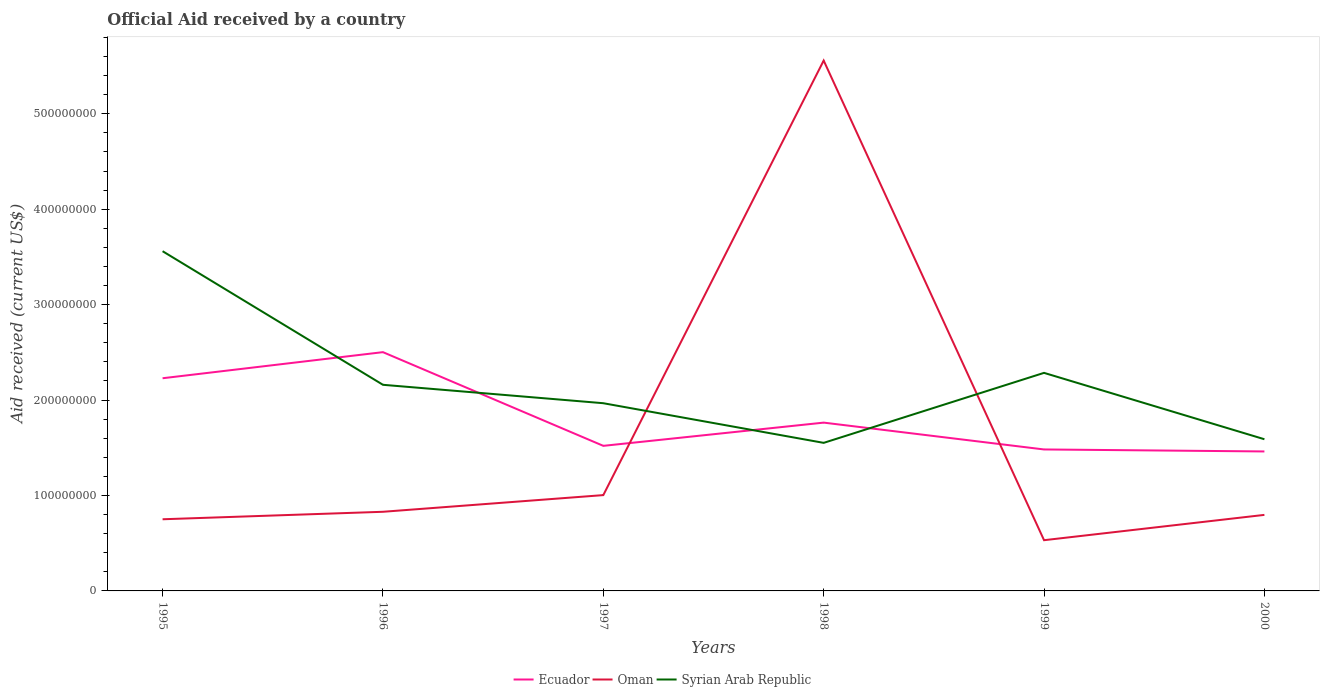How many different coloured lines are there?
Keep it short and to the point. 3. Is the number of lines equal to the number of legend labels?
Ensure brevity in your answer.  Yes. Across all years, what is the maximum net official aid received in Syrian Arab Republic?
Offer a terse response. 1.55e+08. What is the total net official aid received in Oman in the graph?
Your answer should be compact. 4.76e+08. What is the difference between the highest and the second highest net official aid received in Ecuador?
Give a very brief answer. 1.04e+08. What is the difference between the highest and the lowest net official aid received in Oman?
Offer a terse response. 1. Is the net official aid received in Ecuador strictly greater than the net official aid received in Syrian Arab Republic over the years?
Your answer should be very brief. No. How many lines are there?
Keep it short and to the point. 3. How many years are there in the graph?
Provide a short and direct response. 6. Does the graph contain any zero values?
Your answer should be compact. No. How are the legend labels stacked?
Your answer should be very brief. Horizontal. What is the title of the graph?
Provide a succinct answer. Official Aid received by a country. What is the label or title of the X-axis?
Your response must be concise. Years. What is the label or title of the Y-axis?
Provide a succinct answer. Aid received (current US$). What is the Aid received (current US$) of Ecuador in 1995?
Offer a terse response. 2.23e+08. What is the Aid received (current US$) in Oman in 1995?
Keep it short and to the point. 7.51e+07. What is the Aid received (current US$) in Syrian Arab Republic in 1995?
Offer a very short reply. 3.56e+08. What is the Aid received (current US$) in Ecuador in 1996?
Your answer should be very brief. 2.50e+08. What is the Aid received (current US$) in Oman in 1996?
Your answer should be very brief. 8.29e+07. What is the Aid received (current US$) in Syrian Arab Republic in 1996?
Provide a succinct answer. 2.16e+08. What is the Aid received (current US$) in Ecuador in 1997?
Make the answer very short. 1.52e+08. What is the Aid received (current US$) in Oman in 1997?
Ensure brevity in your answer.  1.00e+08. What is the Aid received (current US$) of Syrian Arab Republic in 1997?
Your response must be concise. 1.97e+08. What is the Aid received (current US$) of Ecuador in 1998?
Your answer should be very brief. 1.76e+08. What is the Aid received (current US$) in Oman in 1998?
Provide a short and direct response. 5.56e+08. What is the Aid received (current US$) in Syrian Arab Republic in 1998?
Provide a succinct answer. 1.55e+08. What is the Aid received (current US$) of Ecuador in 1999?
Your response must be concise. 1.48e+08. What is the Aid received (current US$) in Oman in 1999?
Ensure brevity in your answer.  5.32e+07. What is the Aid received (current US$) in Syrian Arab Republic in 1999?
Make the answer very short. 2.28e+08. What is the Aid received (current US$) of Ecuador in 2000?
Make the answer very short. 1.46e+08. What is the Aid received (current US$) of Oman in 2000?
Offer a terse response. 7.97e+07. What is the Aid received (current US$) in Syrian Arab Republic in 2000?
Your response must be concise. 1.59e+08. Across all years, what is the maximum Aid received (current US$) of Ecuador?
Keep it short and to the point. 2.50e+08. Across all years, what is the maximum Aid received (current US$) in Oman?
Provide a succinct answer. 5.56e+08. Across all years, what is the maximum Aid received (current US$) in Syrian Arab Republic?
Your response must be concise. 3.56e+08. Across all years, what is the minimum Aid received (current US$) in Ecuador?
Provide a short and direct response. 1.46e+08. Across all years, what is the minimum Aid received (current US$) of Oman?
Provide a short and direct response. 5.32e+07. Across all years, what is the minimum Aid received (current US$) in Syrian Arab Republic?
Give a very brief answer. 1.55e+08. What is the total Aid received (current US$) in Ecuador in the graph?
Your answer should be very brief. 1.10e+09. What is the total Aid received (current US$) of Oman in the graph?
Provide a succinct answer. 9.47e+08. What is the total Aid received (current US$) in Syrian Arab Republic in the graph?
Ensure brevity in your answer.  1.31e+09. What is the difference between the Aid received (current US$) of Ecuador in 1995 and that in 1996?
Give a very brief answer. -2.73e+07. What is the difference between the Aid received (current US$) in Oman in 1995 and that in 1996?
Give a very brief answer. -7.84e+06. What is the difference between the Aid received (current US$) of Syrian Arab Republic in 1995 and that in 1996?
Make the answer very short. 1.40e+08. What is the difference between the Aid received (current US$) in Ecuador in 1995 and that in 1997?
Your answer should be very brief. 7.08e+07. What is the difference between the Aid received (current US$) in Oman in 1995 and that in 1997?
Ensure brevity in your answer.  -2.53e+07. What is the difference between the Aid received (current US$) in Syrian Arab Republic in 1995 and that in 1997?
Make the answer very short. 1.59e+08. What is the difference between the Aid received (current US$) of Ecuador in 1995 and that in 1998?
Your answer should be very brief. 4.65e+07. What is the difference between the Aid received (current US$) in Oman in 1995 and that in 1998?
Your answer should be compact. -4.81e+08. What is the difference between the Aid received (current US$) of Syrian Arab Republic in 1995 and that in 1998?
Your response must be concise. 2.01e+08. What is the difference between the Aid received (current US$) of Ecuador in 1995 and that in 1999?
Keep it short and to the point. 7.46e+07. What is the difference between the Aid received (current US$) in Oman in 1995 and that in 1999?
Give a very brief answer. 2.19e+07. What is the difference between the Aid received (current US$) in Syrian Arab Republic in 1995 and that in 1999?
Your answer should be very brief. 1.27e+08. What is the difference between the Aid received (current US$) in Ecuador in 1995 and that in 2000?
Make the answer very short. 7.67e+07. What is the difference between the Aid received (current US$) in Oman in 1995 and that in 2000?
Your answer should be compact. -4.58e+06. What is the difference between the Aid received (current US$) of Syrian Arab Republic in 1995 and that in 2000?
Ensure brevity in your answer.  1.97e+08. What is the difference between the Aid received (current US$) of Ecuador in 1996 and that in 1997?
Your answer should be very brief. 9.82e+07. What is the difference between the Aid received (current US$) in Oman in 1996 and that in 1997?
Provide a succinct answer. -1.75e+07. What is the difference between the Aid received (current US$) in Syrian Arab Republic in 1996 and that in 1997?
Give a very brief answer. 1.93e+07. What is the difference between the Aid received (current US$) of Ecuador in 1996 and that in 1998?
Your answer should be very brief. 7.38e+07. What is the difference between the Aid received (current US$) in Oman in 1996 and that in 1998?
Keep it short and to the point. -4.73e+08. What is the difference between the Aid received (current US$) of Syrian Arab Republic in 1996 and that in 1998?
Keep it short and to the point. 6.08e+07. What is the difference between the Aid received (current US$) of Ecuador in 1996 and that in 1999?
Provide a short and direct response. 1.02e+08. What is the difference between the Aid received (current US$) of Oman in 1996 and that in 1999?
Make the answer very short. 2.98e+07. What is the difference between the Aid received (current US$) of Syrian Arab Republic in 1996 and that in 1999?
Your answer should be very brief. -1.25e+07. What is the difference between the Aid received (current US$) of Ecuador in 1996 and that in 2000?
Offer a very short reply. 1.04e+08. What is the difference between the Aid received (current US$) in Oman in 1996 and that in 2000?
Your answer should be very brief. 3.26e+06. What is the difference between the Aid received (current US$) of Syrian Arab Republic in 1996 and that in 2000?
Offer a very short reply. 5.70e+07. What is the difference between the Aid received (current US$) of Ecuador in 1997 and that in 1998?
Ensure brevity in your answer.  -2.43e+07. What is the difference between the Aid received (current US$) in Oman in 1997 and that in 1998?
Your answer should be very brief. -4.55e+08. What is the difference between the Aid received (current US$) of Syrian Arab Republic in 1997 and that in 1998?
Keep it short and to the point. 4.16e+07. What is the difference between the Aid received (current US$) in Ecuador in 1997 and that in 1999?
Offer a very short reply. 3.79e+06. What is the difference between the Aid received (current US$) of Oman in 1997 and that in 1999?
Make the answer very short. 4.72e+07. What is the difference between the Aid received (current US$) of Syrian Arab Republic in 1997 and that in 1999?
Ensure brevity in your answer.  -3.18e+07. What is the difference between the Aid received (current US$) in Ecuador in 1997 and that in 2000?
Your answer should be very brief. 5.88e+06. What is the difference between the Aid received (current US$) of Oman in 1997 and that in 2000?
Provide a short and direct response. 2.07e+07. What is the difference between the Aid received (current US$) in Syrian Arab Republic in 1997 and that in 2000?
Keep it short and to the point. 3.78e+07. What is the difference between the Aid received (current US$) in Ecuador in 1998 and that in 1999?
Offer a terse response. 2.81e+07. What is the difference between the Aid received (current US$) in Oman in 1998 and that in 1999?
Your answer should be very brief. 5.03e+08. What is the difference between the Aid received (current US$) of Syrian Arab Republic in 1998 and that in 1999?
Give a very brief answer. -7.34e+07. What is the difference between the Aid received (current US$) in Ecuador in 1998 and that in 2000?
Your answer should be very brief. 3.02e+07. What is the difference between the Aid received (current US$) in Oman in 1998 and that in 2000?
Your answer should be compact. 4.76e+08. What is the difference between the Aid received (current US$) in Syrian Arab Republic in 1998 and that in 2000?
Make the answer very short. -3.80e+06. What is the difference between the Aid received (current US$) of Ecuador in 1999 and that in 2000?
Provide a short and direct response. 2.09e+06. What is the difference between the Aid received (current US$) in Oman in 1999 and that in 2000?
Your answer should be very brief. -2.65e+07. What is the difference between the Aid received (current US$) of Syrian Arab Republic in 1999 and that in 2000?
Make the answer very short. 6.96e+07. What is the difference between the Aid received (current US$) of Ecuador in 1995 and the Aid received (current US$) of Oman in 1996?
Provide a short and direct response. 1.40e+08. What is the difference between the Aid received (current US$) of Ecuador in 1995 and the Aid received (current US$) of Syrian Arab Republic in 1996?
Provide a short and direct response. 6.87e+06. What is the difference between the Aid received (current US$) of Oman in 1995 and the Aid received (current US$) of Syrian Arab Republic in 1996?
Your answer should be very brief. -1.41e+08. What is the difference between the Aid received (current US$) in Ecuador in 1995 and the Aid received (current US$) in Oman in 1997?
Provide a succinct answer. 1.22e+08. What is the difference between the Aid received (current US$) of Ecuador in 1995 and the Aid received (current US$) of Syrian Arab Republic in 1997?
Ensure brevity in your answer.  2.62e+07. What is the difference between the Aid received (current US$) in Oman in 1995 and the Aid received (current US$) in Syrian Arab Republic in 1997?
Ensure brevity in your answer.  -1.22e+08. What is the difference between the Aid received (current US$) in Ecuador in 1995 and the Aid received (current US$) in Oman in 1998?
Keep it short and to the point. -3.33e+08. What is the difference between the Aid received (current US$) of Ecuador in 1995 and the Aid received (current US$) of Syrian Arab Republic in 1998?
Provide a succinct answer. 6.77e+07. What is the difference between the Aid received (current US$) in Oman in 1995 and the Aid received (current US$) in Syrian Arab Republic in 1998?
Your response must be concise. -8.00e+07. What is the difference between the Aid received (current US$) in Ecuador in 1995 and the Aid received (current US$) in Oman in 1999?
Your answer should be compact. 1.70e+08. What is the difference between the Aid received (current US$) in Ecuador in 1995 and the Aid received (current US$) in Syrian Arab Republic in 1999?
Your response must be concise. -5.63e+06. What is the difference between the Aid received (current US$) in Oman in 1995 and the Aid received (current US$) in Syrian Arab Republic in 1999?
Provide a short and direct response. -1.53e+08. What is the difference between the Aid received (current US$) of Ecuador in 1995 and the Aid received (current US$) of Oman in 2000?
Give a very brief answer. 1.43e+08. What is the difference between the Aid received (current US$) of Ecuador in 1995 and the Aid received (current US$) of Syrian Arab Republic in 2000?
Provide a succinct answer. 6.39e+07. What is the difference between the Aid received (current US$) in Oman in 1995 and the Aid received (current US$) in Syrian Arab Republic in 2000?
Offer a very short reply. -8.38e+07. What is the difference between the Aid received (current US$) of Ecuador in 1996 and the Aid received (current US$) of Oman in 1997?
Provide a succinct answer. 1.50e+08. What is the difference between the Aid received (current US$) in Ecuador in 1996 and the Aid received (current US$) in Syrian Arab Republic in 1997?
Offer a very short reply. 5.35e+07. What is the difference between the Aid received (current US$) of Oman in 1996 and the Aid received (current US$) of Syrian Arab Republic in 1997?
Give a very brief answer. -1.14e+08. What is the difference between the Aid received (current US$) of Ecuador in 1996 and the Aid received (current US$) of Oman in 1998?
Provide a succinct answer. -3.06e+08. What is the difference between the Aid received (current US$) of Ecuador in 1996 and the Aid received (current US$) of Syrian Arab Republic in 1998?
Your answer should be compact. 9.50e+07. What is the difference between the Aid received (current US$) of Oman in 1996 and the Aid received (current US$) of Syrian Arab Republic in 1998?
Provide a succinct answer. -7.22e+07. What is the difference between the Aid received (current US$) of Ecuador in 1996 and the Aid received (current US$) of Oman in 1999?
Ensure brevity in your answer.  1.97e+08. What is the difference between the Aid received (current US$) of Ecuador in 1996 and the Aid received (current US$) of Syrian Arab Republic in 1999?
Offer a terse response. 2.17e+07. What is the difference between the Aid received (current US$) in Oman in 1996 and the Aid received (current US$) in Syrian Arab Republic in 1999?
Your answer should be very brief. -1.46e+08. What is the difference between the Aid received (current US$) of Ecuador in 1996 and the Aid received (current US$) of Oman in 2000?
Offer a very short reply. 1.71e+08. What is the difference between the Aid received (current US$) of Ecuador in 1996 and the Aid received (current US$) of Syrian Arab Republic in 2000?
Give a very brief answer. 9.12e+07. What is the difference between the Aid received (current US$) of Oman in 1996 and the Aid received (current US$) of Syrian Arab Republic in 2000?
Offer a very short reply. -7.60e+07. What is the difference between the Aid received (current US$) in Ecuador in 1997 and the Aid received (current US$) in Oman in 1998?
Offer a very short reply. -4.04e+08. What is the difference between the Aid received (current US$) in Ecuador in 1997 and the Aid received (current US$) in Syrian Arab Republic in 1998?
Your response must be concise. -3.12e+06. What is the difference between the Aid received (current US$) of Oman in 1997 and the Aid received (current US$) of Syrian Arab Republic in 1998?
Make the answer very short. -5.47e+07. What is the difference between the Aid received (current US$) of Ecuador in 1997 and the Aid received (current US$) of Oman in 1999?
Your response must be concise. 9.89e+07. What is the difference between the Aid received (current US$) in Ecuador in 1997 and the Aid received (current US$) in Syrian Arab Republic in 1999?
Give a very brief answer. -7.65e+07. What is the difference between the Aid received (current US$) in Oman in 1997 and the Aid received (current US$) in Syrian Arab Republic in 1999?
Make the answer very short. -1.28e+08. What is the difference between the Aid received (current US$) in Ecuador in 1997 and the Aid received (current US$) in Oman in 2000?
Provide a short and direct response. 7.24e+07. What is the difference between the Aid received (current US$) of Ecuador in 1997 and the Aid received (current US$) of Syrian Arab Republic in 2000?
Your answer should be very brief. -6.92e+06. What is the difference between the Aid received (current US$) of Oman in 1997 and the Aid received (current US$) of Syrian Arab Republic in 2000?
Provide a succinct answer. -5.85e+07. What is the difference between the Aid received (current US$) of Ecuador in 1998 and the Aid received (current US$) of Oman in 1999?
Provide a succinct answer. 1.23e+08. What is the difference between the Aid received (current US$) of Ecuador in 1998 and the Aid received (current US$) of Syrian Arab Republic in 1999?
Offer a terse response. -5.21e+07. What is the difference between the Aid received (current US$) in Oman in 1998 and the Aid received (current US$) in Syrian Arab Republic in 1999?
Ensure brevity in your answer.  3.27e+08. What is the difference between the Aid received (current US$) in Ecuador in 1998 and the Aid received (current US$) in Oman in 2000?
Offer a very short reply. 9.67e+07. What is the difference between the Aid received (current US$) in Ecuador in 1998 and the Aid received (current US$) in Syrian Arab Republic in 2000?
Provide a short and direct response. 1.74e+07. What is the difference between the Aid received (current US$) of Oman in 1998 and the Aid received (current US$) of Syrian Arab Republic in 2000?
Ensure brevity in your answer.  3.97e+08. What is the difference between the Aid received (current US$) of Ecuador in 1999 and the Aid received (current US$) of Oman in 2000?
Provide a succinct answer. 6.86e+07. What is the difference between the Aid received (current US$) of Ecuador in 1999 and the Aid received (current US$) of Syrian Arab Republic in 2000?
Provide a succinct answer. -1.07e+07. What is the difference between the Aid received (current US$) in Oman in 1999 and the Aid received (current US$) in Syrian Arab Republic in 2000?
Provide a succinct answer. -1.06e+08. What is the average Aid received (current US$) in Ecuador per year?
Offer a very short reply. 1.83e+08. What is the average Aid received (current US$) in Oman per year?
Give a very brief answer. 1.58e+08. What is the average Aid received (current US$) in Syrian Arab Republic per year?
Give a very brief answer. 2.19e+08. In the year 1995, what is the difference between the Aid received (current US$) in Ecuador and Aid received (current US$) in Oman?
Provide a short and direct response. 1.48e+08. In the year 1995, what is the difference between the Aid received (current US$) of Ecuador and Aid received (current US$) of Syrian Arab Republic?
Your answer should be compact. -1.33e+08. In the year 1995, what is the difference between the Aid received (current US$) in Oman and Aid received (current US$) in Syrian Arab Republic?
Your response must be concise. -2.81e+08. In the year 1996, what is the difference between the Aid received (current US$) of Ecuador and Aid received (current US$) of Oman?
Provide a succinct answer. 1.67e+08. In the year 1996, what is the difference between the Aid received (current US$) of Ecuador and Aid received (current US$) of Syrian Arab Republic?
Offer a terse response. 3.42e+07. In the year 1996, what is the difference between the Aid received (current US$) in Oman and Aid received (current US$) in Syrian Arab Republic?
Provide a succinct answer. -1.33e+08. In the year 1997, what is the difference between the Aid received (current US$) in Ecuador and Aid received (current US$) in Oman?
Your response must be concise. 5.16e+07. In the year 1997, what is the difference between the Aid received (current US$) of Ecuador and Aid received (current US$) of Syrian Arab Republic?
Your response must be concise. -4.47e+07. In the year 1997, what is the difference between the Aid received (current US$) in Oman and Aid received (current US$) in Syrian Arab Republic?
Offer a very short reply. -9.63e+07. In the year 1998, what is the difference between the Aid received (current US$) in Ecuador and Aid received (current US$) in Oman?
Offer a terse response. -3.79e+08. In the year 1998, what is the difference between the Aid received (current US$) in Ecuador and Aid received (current US$) in Syrian Arab Republic?
Offer a very short reply. 2.12e+07. In the year 1998, what is the difference between the Aid received (current US$) in Oman and Aid received (current US$) in Syrian Arab Republic?
Provide a short and direct response. 4.01e+08. In the year 1999, what is the difference between the Aid received (current US$) in Ecuador and Aid received (current US$) in Oman?
Keep it short and to the point. 9.51e+07. In the year 1999, what is the difference between the Aid received (current US$) in Ecuador and Aid received (current US$) in Syrian Arab Republic?
Offer a terse response. -8.03e+07. In the year 1999, what is the difference between the Aid received (current US$) of Oman and Aid received (current US$) of Syrian Arab Republic?
Give a very brief answer. -1.75e+08. In the year 2000, what is the difference between the Aid received (current US$) in Ecuador and Aid received (current US$) in Oman?
Give a very brief answer. 6.65e+07. In the year 2000, what is the difference between the Aid received (current US$) in Ecuador and Aid received (current US$) in Syrian Arab Republic?
Your answer should be very brief. -1.28e+07. In the year 2000, what is the difference between the Aid received (current US$) of Oman and Aid received (current US$) of Syrian Arab Republic?
Your answer should be compact. -7.93e+07. What is the ratio of the Aid received (current US$) of Ecuador in 1995 to that in 1996?
Make the answer very short. 0.89. What is the ratio of the Aid received (current US$) in Oman in 1995 to that in 1996?
Offer a terse response. 0.91. What is the ratio of the Aid received (current US$) of Syrian Arab Republic in 1995 to that in 1996?
Make the answer very short. 1.65. What is the ratio of the Aid received (current US$) in Ecuador in 1995 to that in 1997?
Your answer should be very brief. 1.47. What is the ratio of the Aid received (current US$) in Oman in 1995 to that in 1997?
Offer a terse response. 0.75. What is the ratio of the Aid received (current US$) of Syrian Arab Republic in 1995 to that in 1997?
Make the answer very short. 1.81. What is the ratio of the Aid received (current US$) of Ecuador in 1995 to that in 1998?
Provide a succinct answer. 1.26. What is the ratio of the Aid received (current US$) of Oman in 1995 to that in 1998?
Offer a terse response. 0.14. What is the ratio of the Aid received (current US$) in Syrian Arab Republic in 1995 to that in 1998?
Provide a succinct answer. 2.29. What is the ratio of the Aid received (current US$) of Ecuador in 1995 to that in 1999?
Make the answer very short. 1.5. What is the ratio of the Aid received (current US$) of Oman in 1995 to that in 1999?
Provide a short and direct response. 1.41. What is the ratio of the Aid received (current US$) in Syrian Arab Republic in 1995 to that in 1999?
Offer a very short reply. 1.56. What is the ratio of the Aid received (current US$) of Ecuador in 1995 to that in 2000?
Give a very brief answer. 1.52. What is the ratio of the Aid received (current US$) of Oman in 1995 to that in 2000?
Keep it short and to the point. 0.94. What is the ratio of the Aid received (current US$) of Syrian Arab Republic in 1995 to that in 2000?
Your answer should be compact. 2.24. What is the ratio of the Aid received (current US$) of Ecuador in 1996 to that in 1997?
Offer a very short reply. 1.65. What is the ratio of the Aid received (current US$) in Oman in 1996 to that in 1997?
Offer a terse response. 0.83. What is the ratio of the Aid received (current US$) in Syrian Arab Republic in 1996 to that in 1997?
Give a very brief answer. 1.1. What is the ratio of the Aid received (current US$) in Ecuador in 1996 to that in 1998?
Your answer should be very brief. 1.42. What is the ratio of the Aid received (current US$) in Oman in 1996 to that in 1998?
Provide a succinct answer. 0.15. What is the ratio of the Aid received (current US$) of Syrian Arab Republic in 1996 to that in 1998?
Offer a very short reply. 1.39. What is the ratio of the Aid received (current US$) in Ecuador in 1996 to that in 1999?
Ensure brevity in your answer.  1.69. What is the ratio of the Aid received (current US$) of Oman in 1996 to that in 1999?
Your response must be concise. 1.56. What is the ratio of the Aid received (current US$) in Syrian Arab Republic in 1996 to that in 1999?
Offer a very short reply. 0.95. What is the ratio of the Aid received (current US$) in Ecuador in 1996 to that in 2000?
Offer a terse response. 1.71. What is the ratio of the Aid received (current US$) of Oman in 1996 to that in 2000?
Provide a short and direct response. 1.04. What is the ratio of the Aid received (current US$) of Syrian Arab Republic in 1996 to that in 2000?
Give a very brief answer. 1.36. What is the ratio of the Aid received (current US$) in Ecuador in 1997 to that in 1998?
Offer a terse response. 0.86. What is the ratio of the Aid received (current US$) in Oman in 1997 to that in 1998?
Your answer should be very brief. 0.18. What is the ratio of the Aid received (current US$) of Syrian Arab Republic in 1997 to that in 1998?
Ensure brevity in your answer.  1.27. What is the ratio of the Aid received (current US$) of Ecuador in 1997 to that in 1999?
Offer a terse response. 1.03. What is the ratio of the Aid received (current US$) in Oman in 1997 to that in 1999?
Keep it short and to the point. 1.89. What is the ratio of the Aid received (current US$) in Syrian Arab Republic in 1997 to that in 1999?
Your answer should be compact. 0.86. What is the ratio of the Aid received (current US$) in Ecuador in 1997 to that in 2000?
Give a very brief answer. 1.04. What is the ratio of the Aid received (current US$) in Oman in 1997 to that in 2000?
Ensure brevity in your answer.  1.26. What is the ratio of the Aid received (current US$) in Syrian Arab Republic in 1997 to that in 2000?
Your answer should be very brief. 1.24. What is the ratio of the Aid received (current US$) in Ecuador in 1998 to that in 1999?
Your answer should be compact. 1.19. What is the ratio of the Aid received (current US$) in Oman in 1998 to that in 1999?
Your answer should be compact. 10.46. What is the ratio of the Aid received (current US$) in Syrian Arab Republic in 1998 to that in 1999?
Keep it short and to the point. 0.68. What is the ratio of the Aid received (current US$) in Ecuador in 1998 to that in 2000?
Keep it short and to the point. 1.21. What is the ratio of the Aid received (current US$) in Oman in 1998 to that in 2000?
Give a very brief answer. 6.98. What is the ratio of the Aid received (current US$) of Syrian Arab Republic in 1998 to that in 2000?
Provide a short and direct response. 0.98. What is the ratio of the Aid received (current US$) in Ecuador in 1999 to that in 2000?
Your response must be concise. 1.01. What is the ratio of the Aid received (current US$) of Oman in 1999 to that in 2000?
Give a very brief answer. 0.67. What is the ratio of the Aid received (current US$) of Syrian Arab Republic in 1999 to that in 2000?
Your response must be concise. 1.44. What is the difference between the highest and the second highest Aid received (current US$) of Ecuador?
Offer a terse response. 2.73e+07. What is the difference between the highest and the second highest Aid received (current US$) of Oman?
Offer a very short reply. 4.55e+08. What is the difference between the highest and the second highest Aid received (current US$) of Syrian Arab Republic?
Keep it short and to the point. 1.27e+08. What is the difference between the highest and the lowest Aid received (current US$) of Ecuador?
Ensure brevity in your answer.  1.04e+08. What is the difference between the highest and the lowest Aid received (current US$) in Oman?
Give a very brief answer. 5.03e+08. What is the difference between the highest and the lowest Aid received (current US$) in Syrian Arab Republic?
Keep it short and to the point. 2.01e+08. 